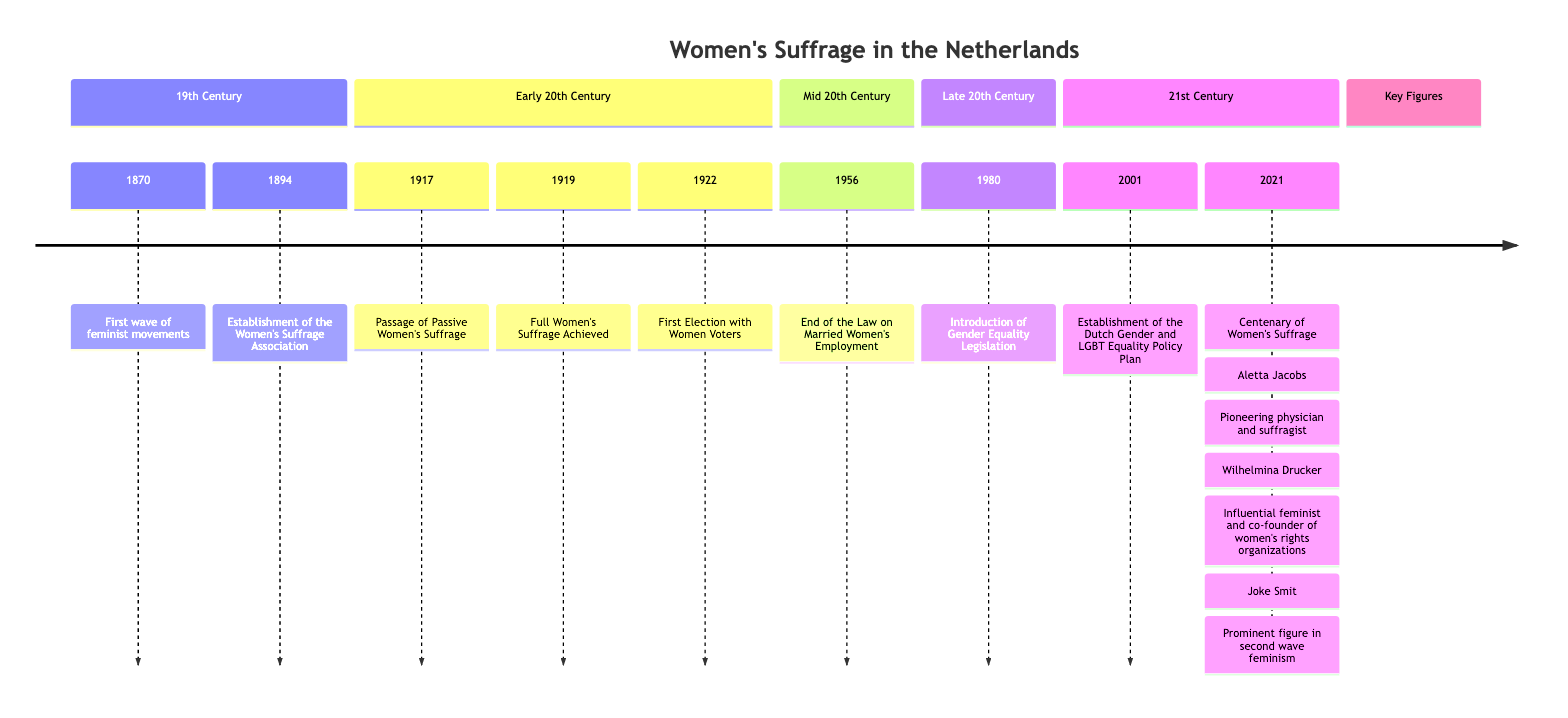What year saw the establishment of the Women's Suffrage Association? The diagram indicates that the Women's Suffrage Association was established in 1894. It is marked as a key event in the timeline under the 19th Century section.
Answer: 1894 Who was a key figure in the fight for women's voting rights in the Netherlands? The timeline highlights Aletta Jacobs as a key figure, specifying her influential role as a suffragist. This information is included in the section detailing influential figures.
Answer: Aletta Jacobs What significant event occurred in 1919? According to the timeline, 1919 is noted for the achievement of full women's suffrage. This is a significant milestone marked in the early 20th Century section.
Answer: Full Women's Suffrage Achieved In what year did women in the Netherlands vote for the first time? The timeline states that women voted for the first time in a general election in 1922, which is highlighted in the section covering significant events of the early 20th Century.
Answer: 1922 What does the 2001 event in the timeline summarize? The event in 2001 describes the establishment of the Dutch Gender and LGBT Equality Policy Plan. This detail is captured in the 21st Century section of the timeline.
Answer: Establishment of the Dutch Gender and LGBT Equality Policy Plan How many major events are listed in the 20th Century? Upon reviewing the timeline, there are five key events that are highlighted across the sections of early to mid-20th Century. The events span from 1917 to 1956.
Answer: 5 Which movement began in 1870? The timeline indicates that the first wave of feminist movements began in 1870. This is marked in the 19th Century section as an initial point of focus for women's rights.
Answer: First wave of feminist movements What major change occurred for women's employment in 1956? The timeline reveals that in 1956, the law that required women to leave their jobs upon marriage was abolished, allowing for greater workforce participation. This event is located in the mid-20th Century section.
Answer: End of the Law on Married Women's Employment Who co-founded the Free Women's Association? The timeline identifies Wilhelmina Drucker as an influential feminist and co-founder of several women's rights organizations, including the Free Women's Association. This information can be found in the influential figures section.
Answer: Wilhelmina Drucker 